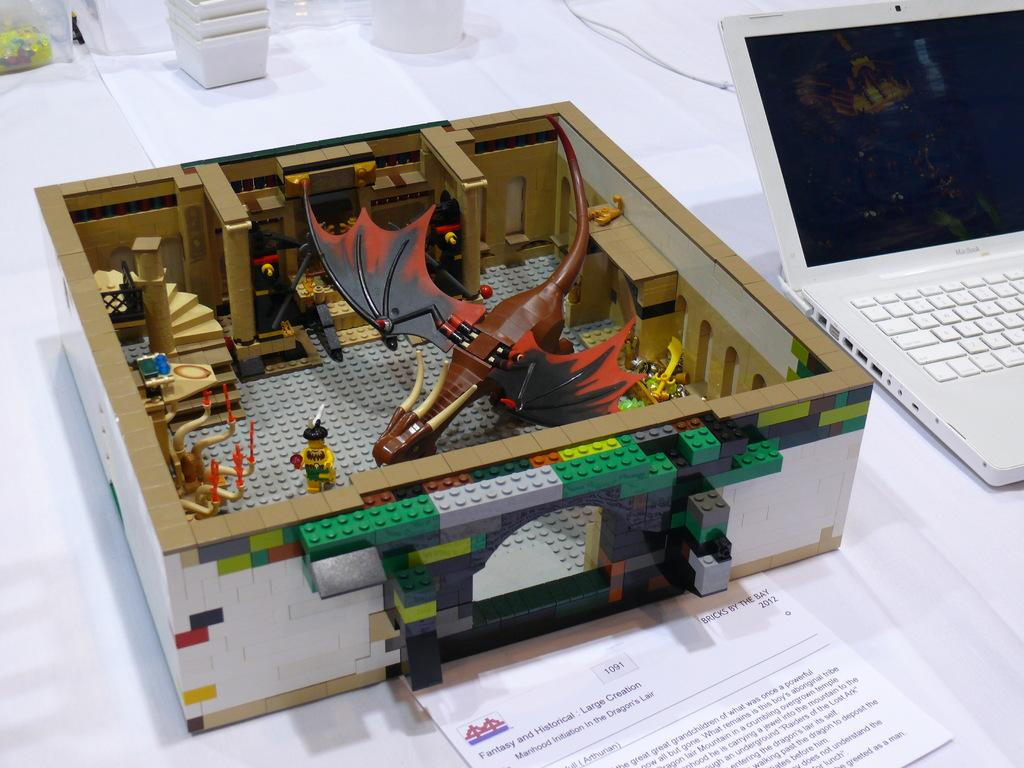What electronic device is visible in the image? There is a laptop in the image. What other objects are present on the table in the image? There is a box and paper in the image. What surface are the laptop, box, and paper placed on? The laptop, box, and paper are placed on a table. What type of apple is being protested against in the image? There is no apple or protest present in the image; it only features a laptop, box, and paper on a table. 